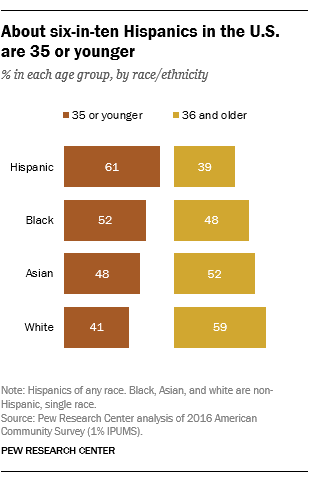Mention a couple of crucial points in this snapshot. The age group that the dark orange represents is 35 years old or younger. The value of Asia in the age group 35 or younger is not more than the older age group, which is 36 or above. 